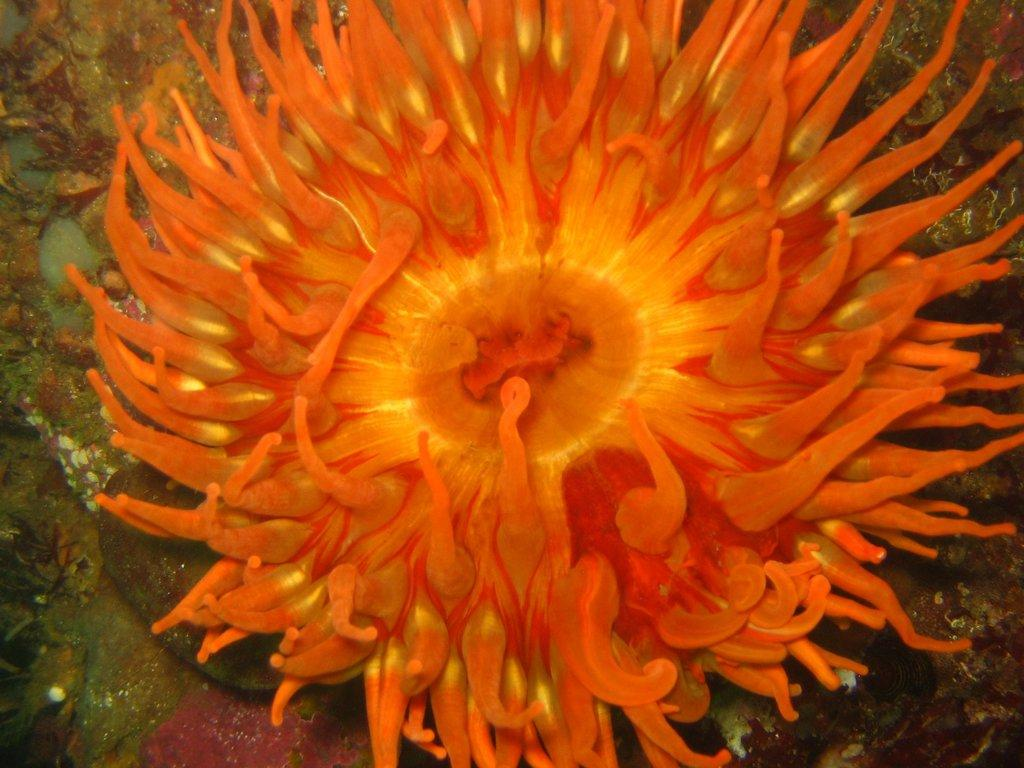What type of marine life is visible in the image? There are sea anemones in the image. What type of chess piece is sitting on the cushion in the image? There is no chess piece or cushion present in the image; it features sea anemones. How many sea anemones are visible in the image, and what is their mode of transportation? The number of sea anemones cannot be determined from the image, and they do not have a mode of transportation as they are stationary marine life. 